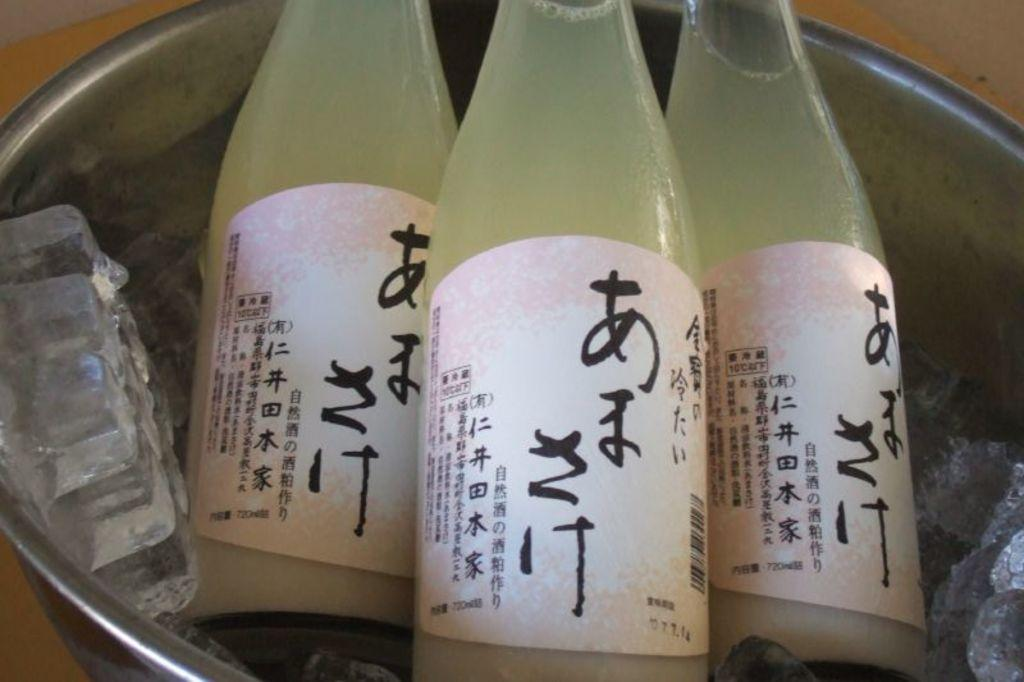What objects are present in the image? There are bottles in the image. How are the bottles arranged or contained? The bottles are in a vessel. What is present in the vessel along with the bottles? There is ice in the vessel with the bottles. Can you tell me how many firemen are visible in the image? There are no firemen present in the image; it features bottles in a vessel with ice. What type of building is depicted in the image? There is no building depicted in the image; it features bottles in a vessel with ice. 